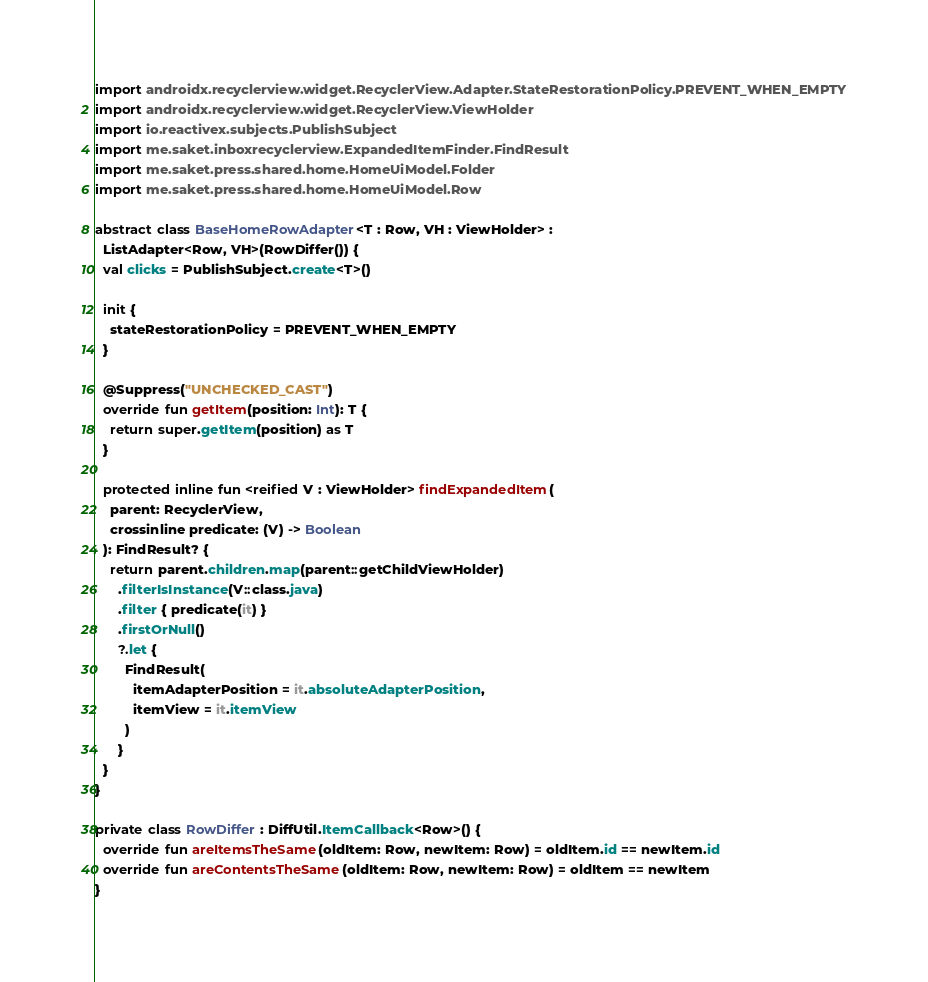<code> <loc_0><loc_0><loc_500><loc_500><_Kotlin_>import androidx.recyclerview.widget.RecyclerView.Adapter.StateRestorationPolicy.PREVENT_WHEN_EMPTY
import androidx.recyclerview.widget.RecyclerView.ViewHolder
import io.reactivex.subjects.PublishSubject
import me.saket.inboxrecyclerview.ExpandedItemFinder.FindResult
import me.saket.press.shared.home.HomeUiModel.Folder
import me.saket.press.shared.home.HomeUiModel.Row

abstract class BaseHomeRowAdapter<T : Row, VH : ViewHolder> :
  ListAdapter<Row, VH>(RowDiffer()) {
  val clicks = PublishSubject.create<T>()

  init {
    stateRestorationPolicy = PREVENT_WHEN_EMPTY
  }

  @Suppress("UNCHECKED_CAST")
  override fun getItem(position: Int): T {
    return super.getItem(position) as T
  }

  protected inline fun <reified V : ViewHolder> findExpandedItem(
    parent: RecyclerView,
    crossinline predicate: (V) -> Boolean
  ): FindResult? {
    return parent.children.map(parent::getChildViewHolder)
      .filterIsInstance(V::class.java)
      .filter { predicate(it) }
      .firstOrNull()
      ?.let {
        FindResult(
          itemAdapterPosition = it.absoluteAdapterPosition,
          itemView = it.itemView
        )
      }
  }
}

private class RowDiffer : DiffUtil.ItemCallback<Row>() {
  override fun areItemsTheSame(oldItem: Row, newItem: Row) = oldItem.id == newItem.id
  override fun areContentsTheSame(oldItem: Row, newItem: Row) = oldItem == newItem
}
</code> 